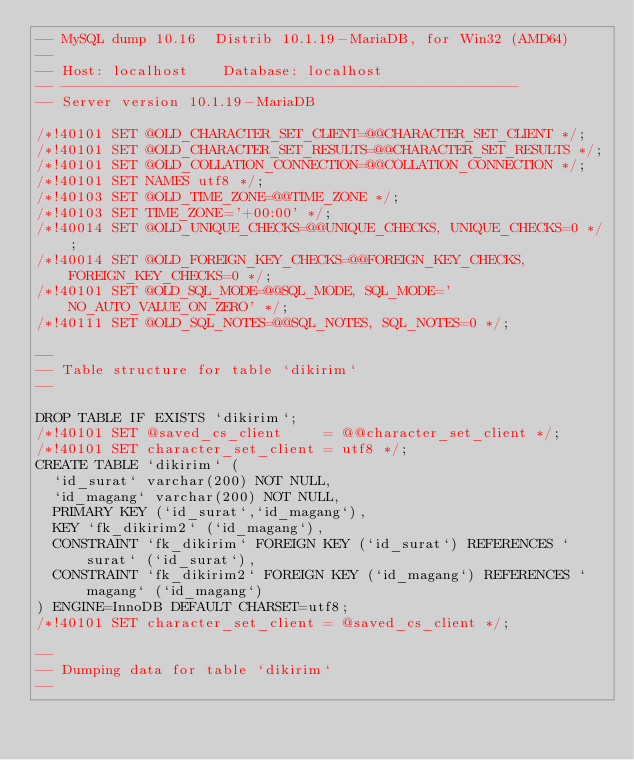<code> <loc_0><loc_0><loc_500><loc_500><_SQL_>-- MySQL dump 10.16  Distrib 10.1.19-MariaDB, for Win32 (AMD64)
--
-- Host: localhost    Database: localhost
-- ------------------------------------------------------
-- Server version	10.1.19-MariaDB

/*!40101 SET @OLD_CHARACTER_SET_CLIENT=@@CHARACTER_SET_CLIENT */;
/*!40101 SET @OLD_CHARACTER_SET_RESULTS=@@CHARACTER_SET_RESULTS */;
/*!40101 SET @OLD_COLLATION_CONNECTION=@@COLLATION_CONNECTION */;
/*!40101 SET NAMES utf8 */;
/*!40103 SET @OLD_TIME_ZONE=@@TIME_ZONE */;
/*!40103 SET TIME_ZONE='+00:00' */;
/*!40014 SET @OLD_UNIQUE_CHECKS=@@UNIQUE_CHECKS, UNIQUE_CHECKS=0 */;
/*!40014 SET @OLD_FOREIGN_KEY_CHECKS=@@FOREIGN_KEY_CHECKS, FOREIGN_KEY_CHECKS=0 */;
/*!40101 SET @OLD_SQL_MODE=@@SQL_MODE, SQL_MODE='NO_AUTO_VALUE_ON_ZERO' */;
/*!40111 SET @OLD_SQL_NOTES=@@SQL_NOTES, SQL_NOTES=0 */;

--
-- Table structure for table `dikirim`
--

DROP TABLE IF EXISTS `dikirim`;
/*!40101 SET @saved_cs_client     = @@character_set_client */;
/*!40101 SET character_set_client = utf8 */;
CREATE TABLE `dikirim` (
  `id_surat` varchar(200) NOT NULL,
  `id_magang` varchar(200) NOT NULL,
  PRIMARY KEY (`id_surat`,`id_magang`),
  KEY `fk_dikirim2` (`id_magang`),
  CONSTRAINT `fk_dikirim` FOREIGN KEY (`id_surat`) REFERENCES `surat` (`id_surat`),
  CONSTRAINT `fk_dikirim2` FOREIGN KEY (`id_magang`) REFERENCES `magang` (`id_magang`)
) ENGINE=InnoDB DEFAULT CHARSET=utf8;
/*!40101 SET character_set_client = @saved_cs_client */;

--
-- Dumping data for table `dikirim`
--
</code> 